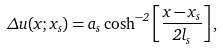<formula> <loc_0><loc_0><loc_500><loc_500>\Delta u ( x ; x _ { s } ) = a _ { s } \cosh ^ { - 2 } \left [ \frac { x - x _ { s } } { 2 l _ { s } } \right ] ,</formula> 